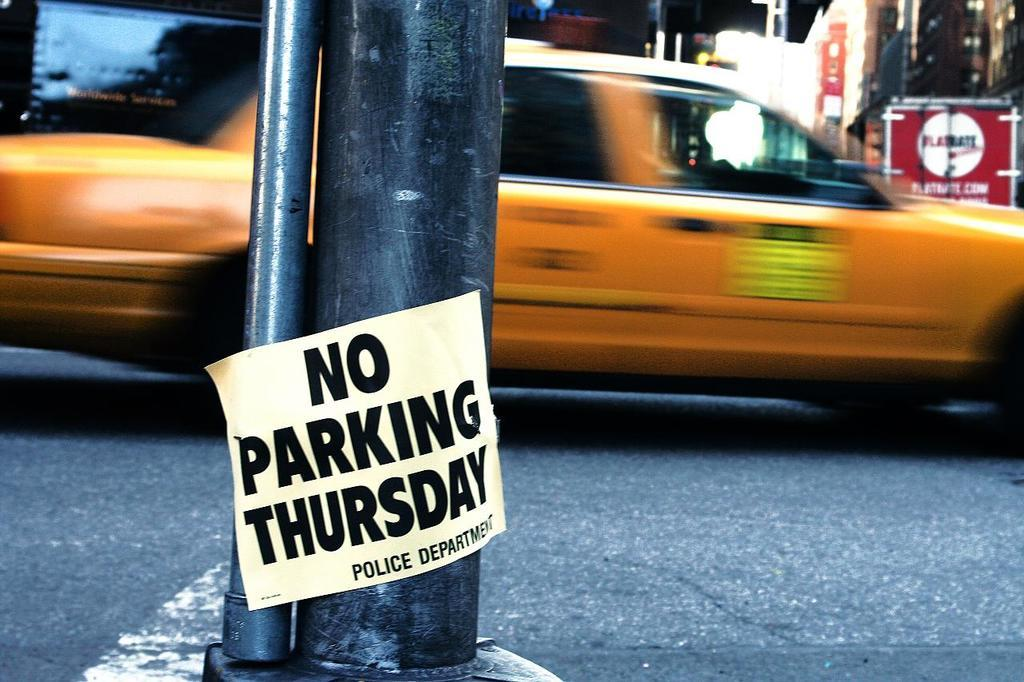<image>
Provide a brief description of the given image. A sign on a post noting that no one should park there on Thursday. 